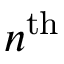<formula> <loc_0><loc_0><loc_500><loc_500>n ^ { t h }</formula> 